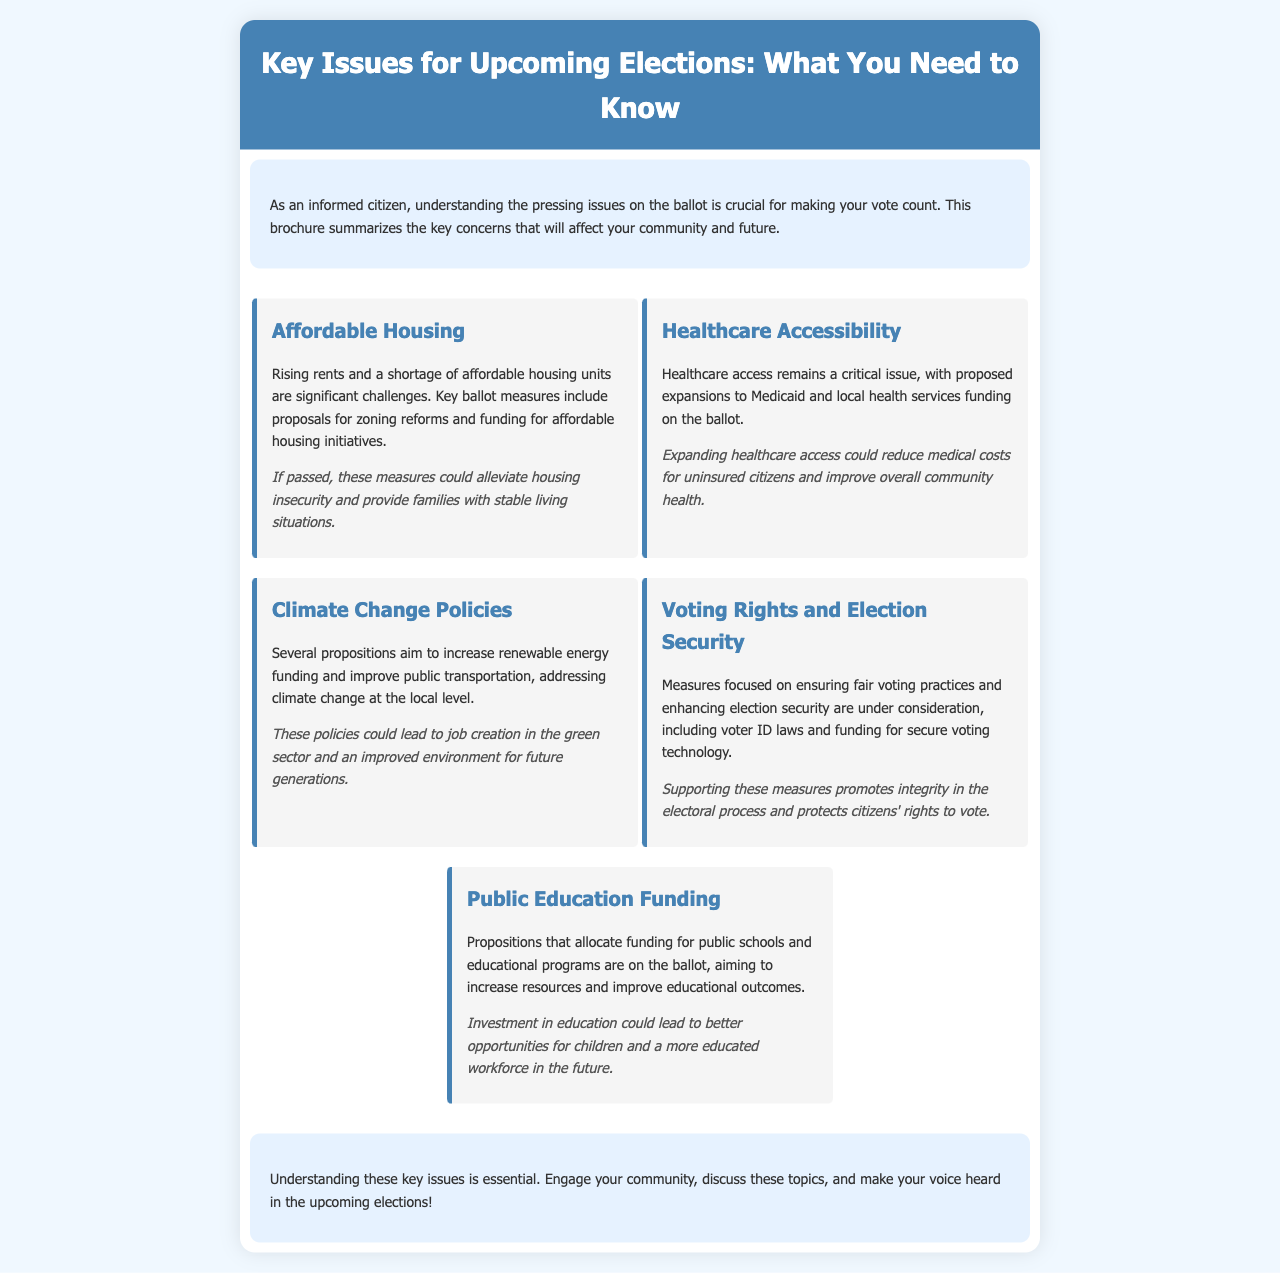What are the key issues highlighted in the brochure? The brochure outlines five key issues: Affordable Housing, Healthcare Accessibility, Climate Change Policies, Voting Rights and Election Security, and Public Education Funding.
Answer: Affordable Housing, Healthcare Accessibility, Climate Change Policies, Voting Rights and Election Security, Public Education Funding What is the color of the brochure's header? The header has a background color defined in the style as #4682b4, which is a shade of blue.
Answer: Blue What implication is associated with Affordable Housing measures? The implication states that if passed, these measures could alleviate housing insecurity and provide families with stable living situations.
Answer: Alleviate housing insecurity What issue addresses the funding for local health services? Healthcare Accessibility is the issue that discusses proposed expansions to Medicaid and funding for local health services.
Answer: Healthcare Accessibility What is one proposal related to Climate Change Policies? The brochure mentions that several propositions aim to increase renewable energy funding and improve public transportation.
Answer: Increase renewable energy funding What could be a potential outcome of Public Education Funding propositions? Investment in education could lead to better opportunities for children and a more educated workforce in the future.
Answer: Better opportunities for children What category does "voter ID laws" fall under? Voter ID laws are part of a broader category of measures focused on ensuring fair voting practices and enhancing election security.
Answer: Election Security How does the brochure suggest citizens engage with the discussed issues? The brochure encourages citizens to engage their community and discuss these key issues to make their voices heard in the upcoming elections.
Answer: Engage your community What is the main purpose of the brochure? The main purpose is to summarize key concerns that will affect the community and future, helping citizens make informed voting decisions.
Answer: Inform citizens about key issues 